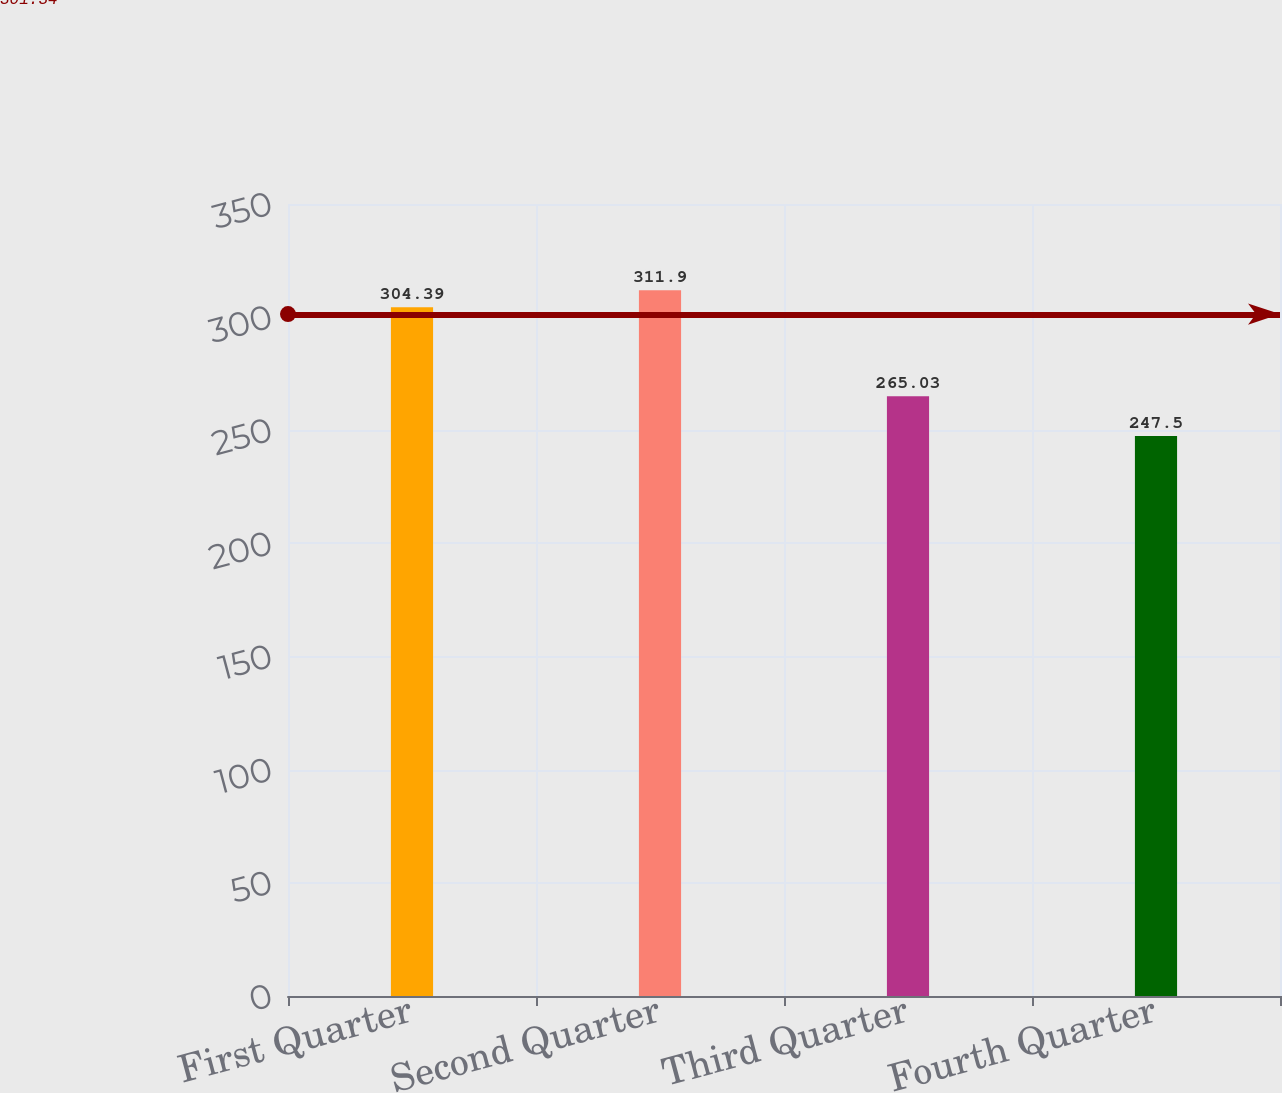Convert chart to OTSL. <chart><loc_0><loc_0><loc_500><loc_500><bar_chart><fcel>First Quarter<fcel>Second Quarter<fcel>Third Quarter<fcel>Fourth Quarter<nl><fcel>304.39<fcel>311.9<fcel>265.03<fcel>247.5<nl></chart> 